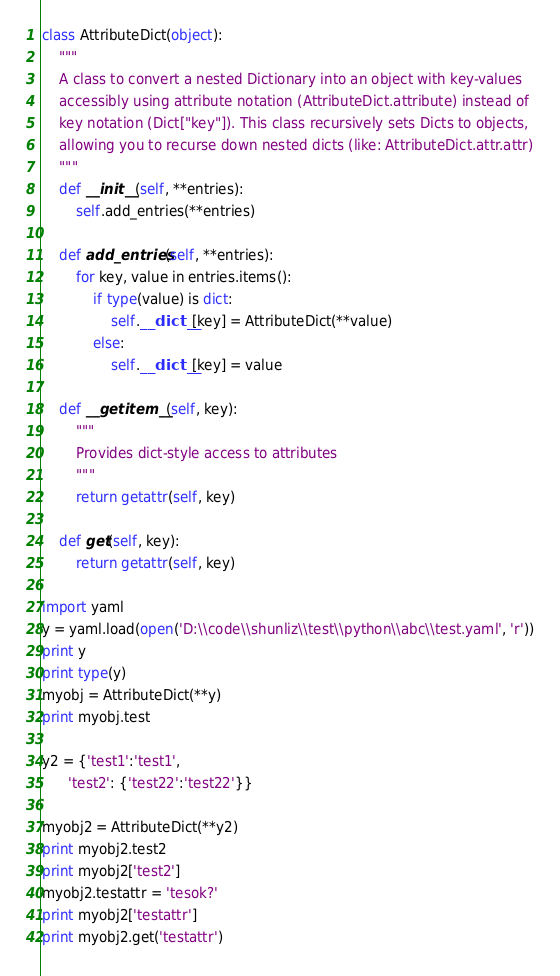<code> <loc_0><loc_0><loc_500><loc_500><_Python_>class AttributeDict(object):
	"""
	A class to convert a nested Dictionary into an object with key-values
	accessibly using attribute notation (AttributeDict.attribute) instead of
	key notation (Dict["key"]). This class recursively sets Dicts to objects,
	allowing you to recurse down nested dicts (like: AttributeDict.attr.attr)
	"""
	def __init__(self, **entries):
		self.add_entries(**entries)

	def add_entries(self, **entries):
		for key, value in entries.items():
			if type(value) is dict:
				self.__dict__[key] = AttributeDict(**value)
			else:
				self.__dict__[key] = value

	def __getitem__(self, key):
		"""
		Provides dict-style access to attributes
		"""
		return getattr(self, key)

	def get(self, key):
	    return getattr(self, key)

import yaml
y = yaml.load(open('D:\\code\\shunliz\\test\\python\\abc\\test.yaml', 'r'))
print y
print type(y)
myobj = AttributeDict(**y)
print myobj.test

y2 = {'test1':'test1',
      'test2': {'test22':'test22'}}

myobj2 = AttributeDict(**y2)
print myobj2.test2
print myobj2['test2']
myobj2.testattr = 'tesok?'
print myobj2['testattr']
print myobj2.get('testattr')</code> 